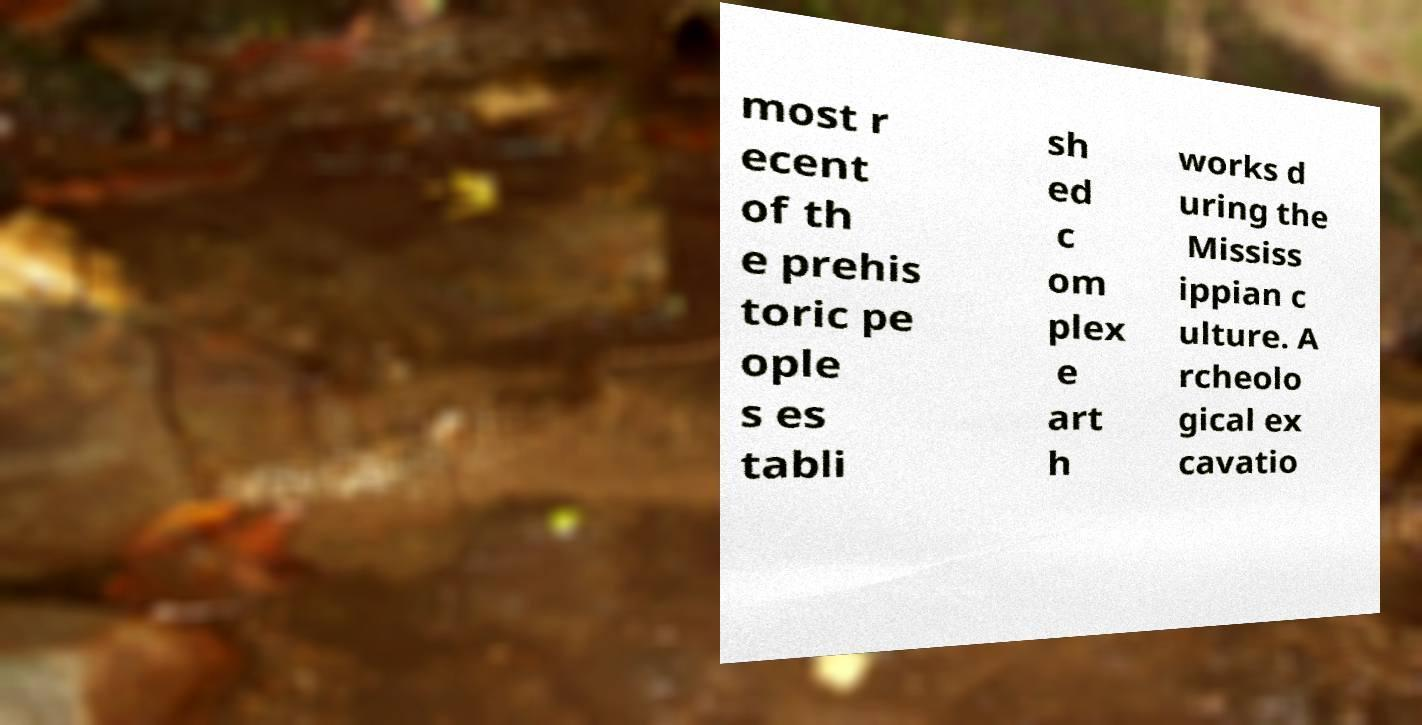Could you assist in decoding the text presented in this image and type it out clearly? most r ecent of th e prehis toric pe ople s es tabli sh ed c om plex e art h works d uring the Mississ ippian c ulture. A rcheolo gical ex cavatio 